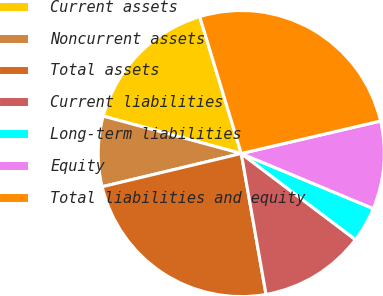<chart> <loc_0><loc_0><loc_500><loc_500><pie_chart><fcel>Current assets<fcel>Noncurrent assets<fcel>Total assets<fcel>Current liabilities<fcel>Long-term liabilities<fcel>Equity<fcel>Total liabilities and equity<nl><fcel>16.1%<fcel>7.94%<fcel>24.04%<fcel>11.95%<fcel>3.99%<fcel>9.94%<fcel>26.04%<nl></chart> 